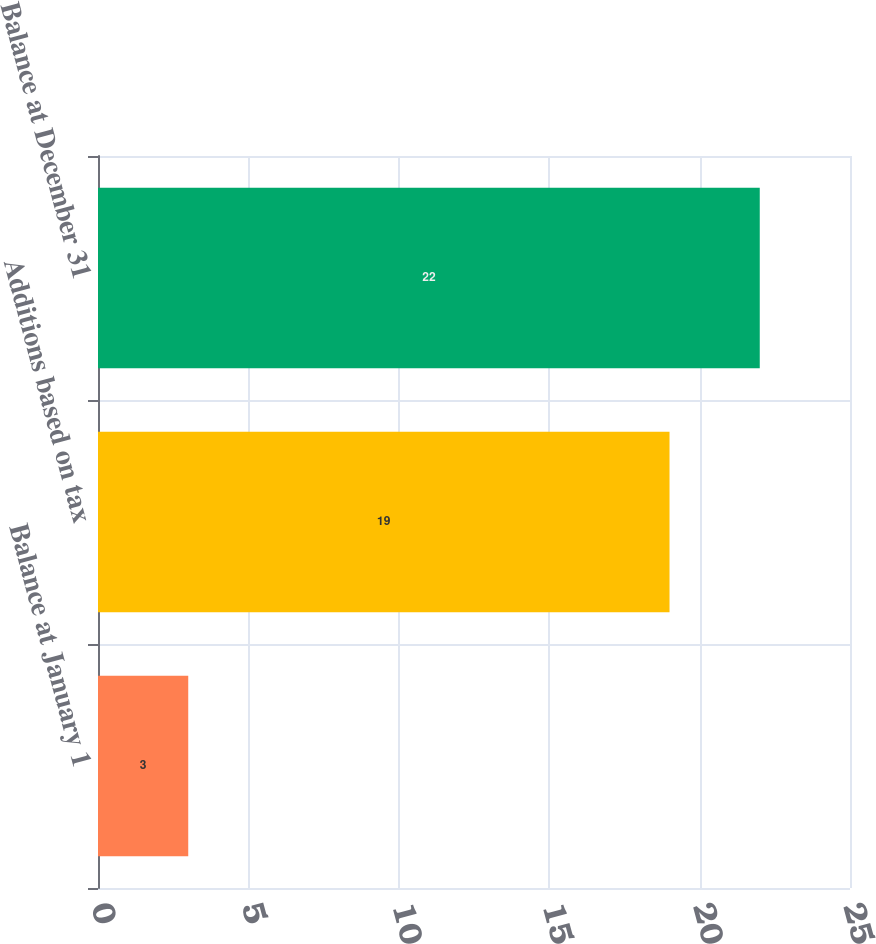Convert chart to OTSL. <chart><loc_0><loc_0><loc_500><loc_500><bar_chart><fcel>Balance at January 1<fcel>Additions based on tax<fcel>Balance at December 31<nl><fcel>3<fcel>19<fcel>22<nl></chart> 